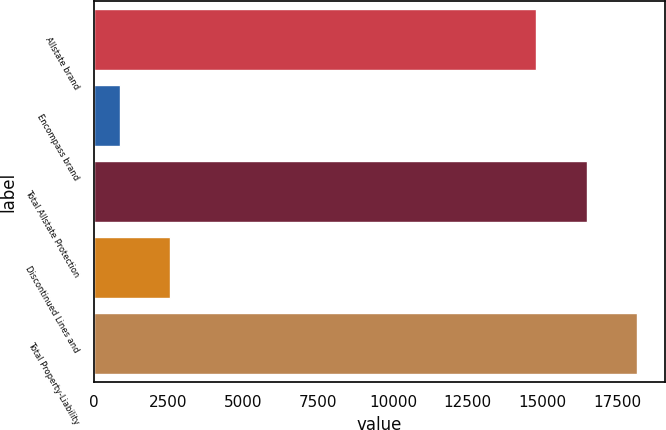<chart> <loc_0><loc_0><loc_500><loc_500><bar_chart><fcel>Allstate brand<fcel>Encompass brand<fcel>Total Allstate Protection<fcel>Discontinued Lines and<fcel>Total Property-Liability<nl><fcel>14792<fcel>859<fcel>16484.8<fcel>2551.8<fcel>18177.6<nl></chart> 